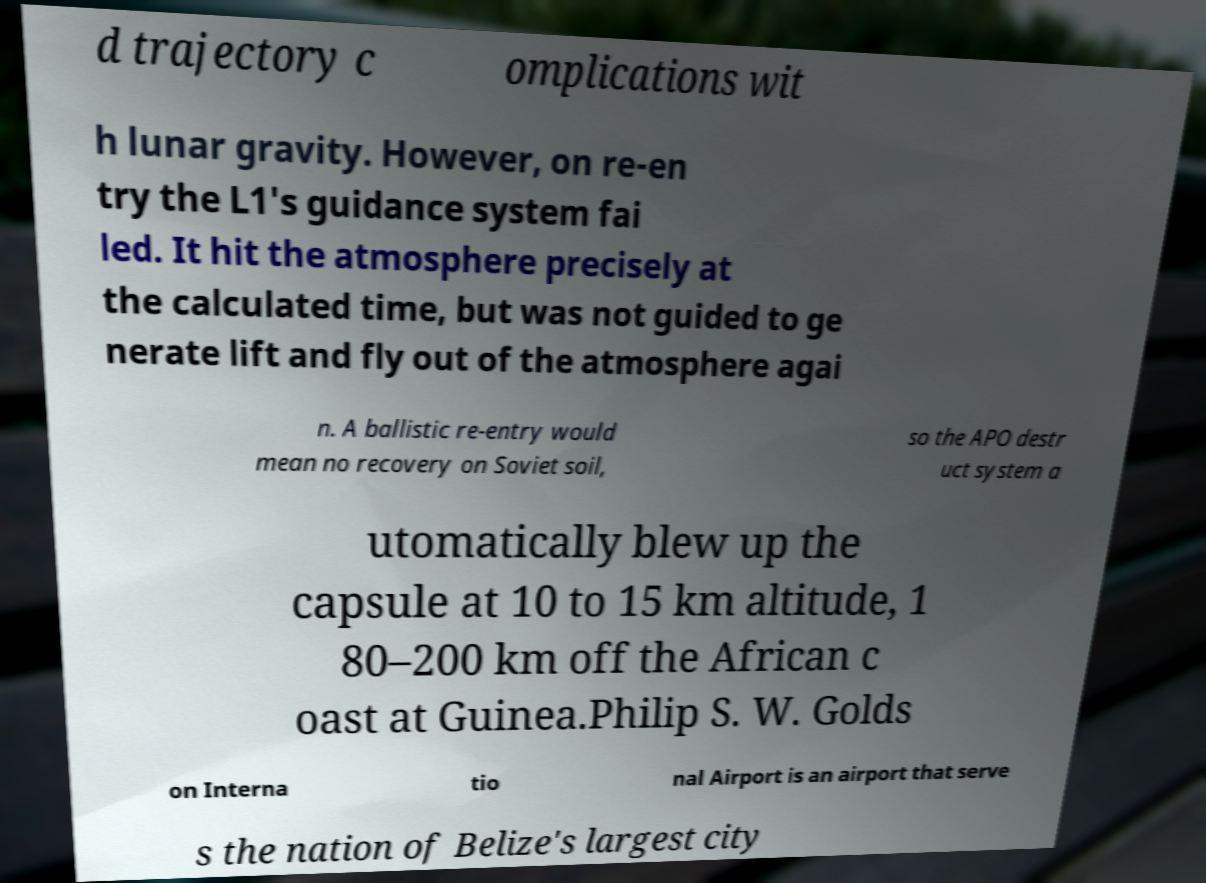For documentation purposes, I need the text within this image transcribed. Could you provide that? d trajectory c omplications wit h lunar gravity. However, on re-en try the L1's guidance system fai led. It hit the atmosphere precisely at the calculated time, but was not guided to ge nerate lift and fly out of the atmosphere agai n. A ballistic re-entry would mean no recovery on Soviet soil, so the APO destr uct system a utomatically blew up the capsule at 10 to 15 km altitude, 1 80–200 km off the African c oast at Guinea.Philip S. W. Golds on Interna tio nal Airport is an airport that serve s the nation of Belize's largest city 